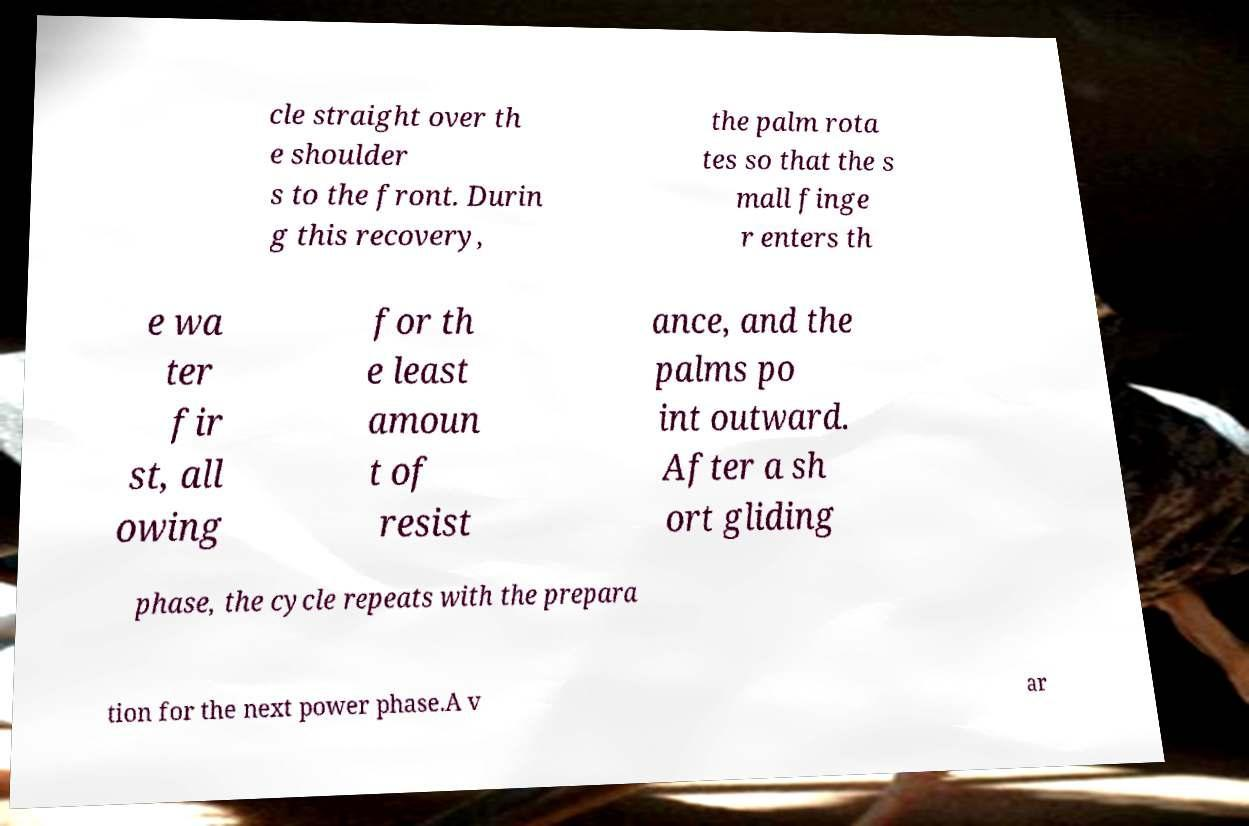Could you extract and type out the text from this image? cle straight over th e shoulder s to the front. Durin g this recovery, the palm rota tes so that the s mall finge r enters th e wa ter fir st, all owing for th e least amoun t of resist ance, and the palms po int outward. After a sh ort gliding phase, the cycle repeats with the prepara tion for the next power phase.A v ar 